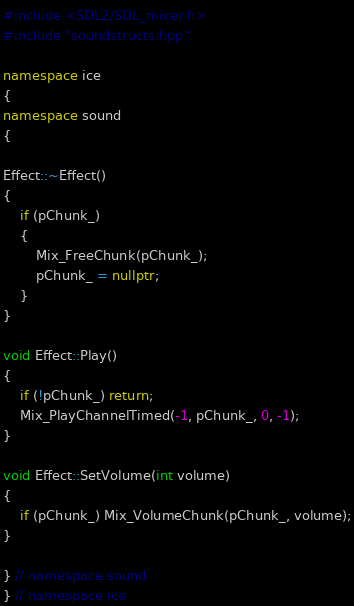Convert code to text. <code><loc_0><loc_0><loc_500><loc_500><_C++_>#include <SDL2/SDL_mixer.h>
#include "soundstructs.hpp"

namespace ice
{
namespace sound
{

Effect::~Effect()
{
    if (pChunk_)
    {
        Mix_FreeChunk(pChunk_);
        pChunk_ = nullptr;
    }
}

void Effect::Play()
{
    if (!pChunk_) return;
    Mix_PlayChannelTimed(-1, pChunk_, 0, -1);
}

void Effect::SetVolume(int volume)
{
    if (pChunk_) Mix_VolumeChunk(pChunk_, volume);
}

} // namespace sound
} // namespace ice




















</code> 